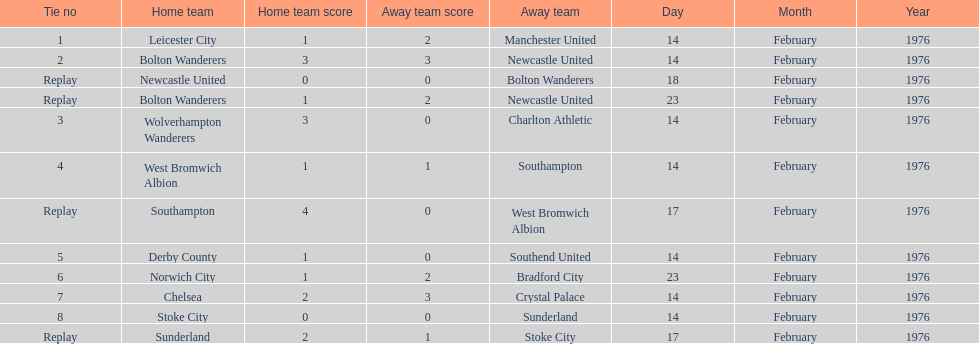What is the difference between southampton's score and sunderland's score? 2 goals. Can you give me this table as a dict? {'header': ['Tie no', 'Home team', 'Home team score', 'Away team score', 'Away team', 'Day', 'Month', 'Year'], 'rows': [['1', 'Leicester City', '1', '2', 'Manchester United', '14', 'February', '1976'], ['2', 'Bolton Wanderers', '3', '3', 'Newcastle United', '14', 'February', '1976'], ['Replay', 'Newcastle United', '0', '0', 'Bolton Wanderers', '18', 'February', '1976'], ['Replay', 'Bolton Wanderers', '1', '2', 'Newcastle United', '23', 'February', '1976'], ['3', 'Wolverhampton Wanderers', '3', '0', 'Charlton Athletic', '14', 'February', '1976'], ['4', 'West Bromwich Albion', '1', '1', 'Southampton', '14', 'February', '1976'], ['Replay', 'Southampton', '4', '0', 'West Bromwich Albion', '17', 'February', '1976'], ['5', 'Derby County', '1', '0', 'Southend United', '14', 'February', '1976'], ['6', 'Norwich City', '1', '2', 'Bradford City', '23', 'February', '1976'], ['7', 'Chelsea', '2', '3', 'Crystal Palace', '14', 'February', '1976'], ['8', 'Stoke City', '0', '0', 'Sunderland', '14', 'February', '1976'], ['Replay', 'Sunderland', '2', '1', 'Stoke City', '17', 'February', '1976']]} 